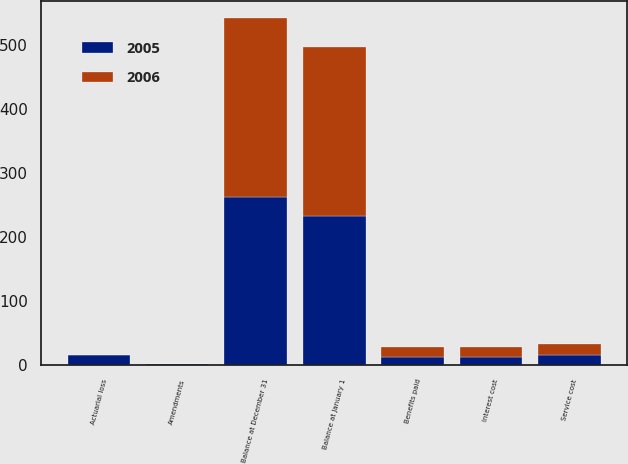<chart> <loc_0><loc_0><loc_500><loc_500><stacked_bar_chart><ecel><fcel>Balance at January 1<fcel>Service cost<fcel>Interest cost<fcel>Actuarial loss<fcel>Amendments<fcel>Benefits paid<fcel>Balance at December 31<nl><fcel>2006<fcel>263.4<fcel>17.1<fcel>14.5<fcel>1.4<fcel>0.7<fcel>15.1<fcel>278.5<nl><fcel>2005<fcel>233<fcel>15.7<fcel>13.8<fcel>15.5<fcel>1.8<fcel>12.8<fcel>263.4<nl></chart> 